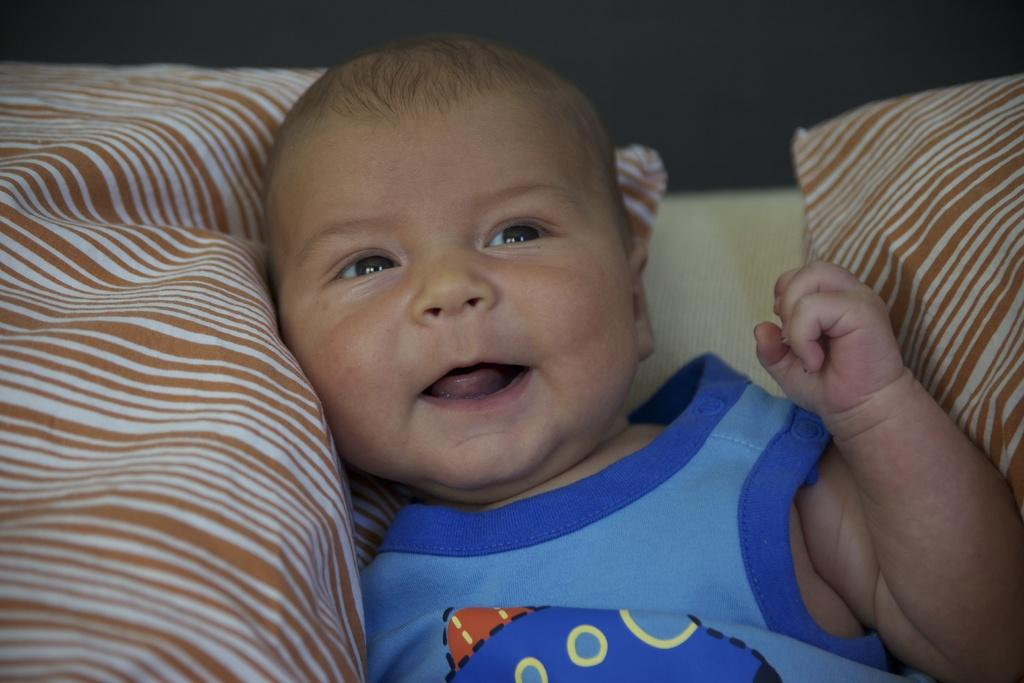What is the main subject of the image? There is a baby in the image. What is the baby wearing? The baby is wearing a blue t-shirt. Where is the baby located in the image? The baby is laying on a bed. What is present on both sides of the baby? There are pillows on both sides of the baby. What type of club does the baby belong to in the image? There is no club mentioned or depicted in the image; it simply shows a baby laying on a bed with pillows on both sides. 